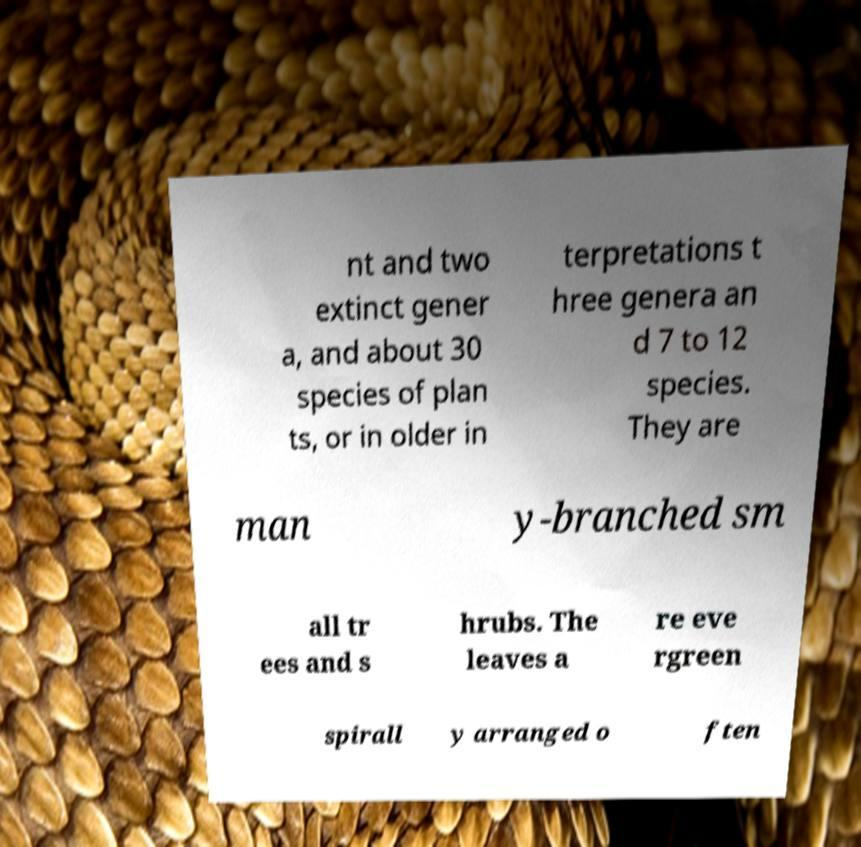What messages or text are displayed in this image? I need them in a readable, typed format. nt and two extinct gener a, and about 30 species of plan ts, or in older in terpretations t hree genera an d 7 to 12 species. They are man y-branched sm all tr ees and s hrubs. The leaves a re eve rgreen spirall y arranged o ften 